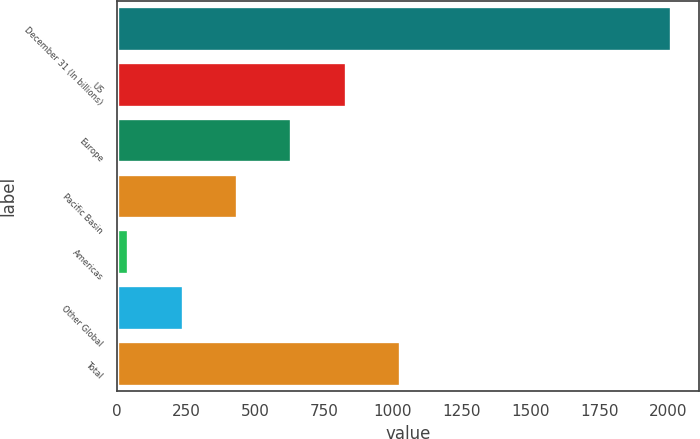Convert chart. <chart><loc_0><loc_0><loc_500><loc_500><bar_chart><fcel>December 31 (In billions)<fcel>US<fcel>Europe<fcel>Pacific Basin<fcel>Americas<fcel>Other Global<fcel>Total<nl><fcel>2010<fcel>828<fcel>631<fcel>434<fcel>40<fcel>237<fcel>1025<nl></chart> 